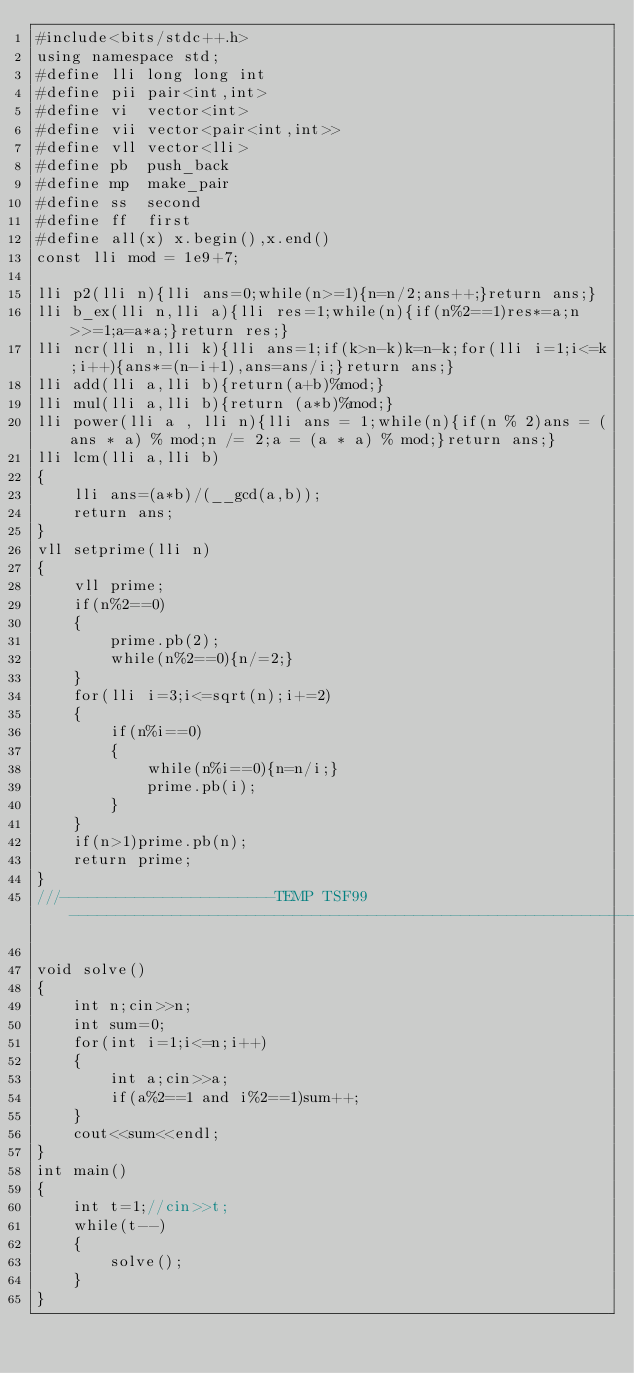Convert code to text. <code><loc_0><loc_0><loc_500><loc_500><_C++_>#include<bits/stdc++.h>
using namespace std;
#define lli long long int
#define pii pair<int,int>
#define vi  vector<int>
#define vii vector<pair<int,int>>
#define vll vector<lli>
#define pb  push_back
#define mp  make_pair
#define ss  second
#define ff  first
#define all(x) x.begin(),x.end()
const lli mod = 1e9+7;

lli p2(lli n){lli ans=0;while(n>=1){n=n/2;ans++;}return ans;}
lli b_ex(lli n,lli a){lli res=1;while(n){if(n%2==1)res*=a;n>>=1;a=a*a;}return res;}
lli ncr(lli n,lli k){lli ans=1;if(k>n-k)k=n-k;for(lli i=1;i<=k;i++){ans*=(n-i+1),ans=ans/i;}return ans;}
lli add(lli a,lli b){return(a+b)%mod;}
lli mul(lli a,lli b){return (a*b)%mod;}
lli power(lli a , lli n){lli ans = 1;while(n){if(n % 2)ans = (ans * a) % mod;n /= 2;a = (a * a) % mod;}return ans;}
lli lcm(lli a,lli b)
{
    lli ans=(a*b)/(__gcd(a,b));
    return ans;
}
vll setprime(lli n)
{
    vll prime;
    if(n%2==0)
    {
        prime.pb(2);
        while(n%2==0){n/=2;}
    }
    for(lli i=3;i<=sqrt(n);i+=2)
    {
        if(n%i==0)
        {
            while(n%i==0){n=n/i;}
            prime.pb(i);
        }
    }
    if(n>1)prime.pb(n);
    return prime;
}
///-----------------------TEMP TSF99--------------------------------------------------------------------------------------///

void solve()
{
    int n;cin>>n;
    int sum=0;
    for(int i=1;i<=n;i++)
    {
        int a;cin>>a;
        if(a%2==1 and i%2==1)sum++;
    }
    cout<<sum<<endl;
}
int main()
{
    int t=1;//cin>>t;
    while(t--)
    {
        solve();
    }
}
</code> 